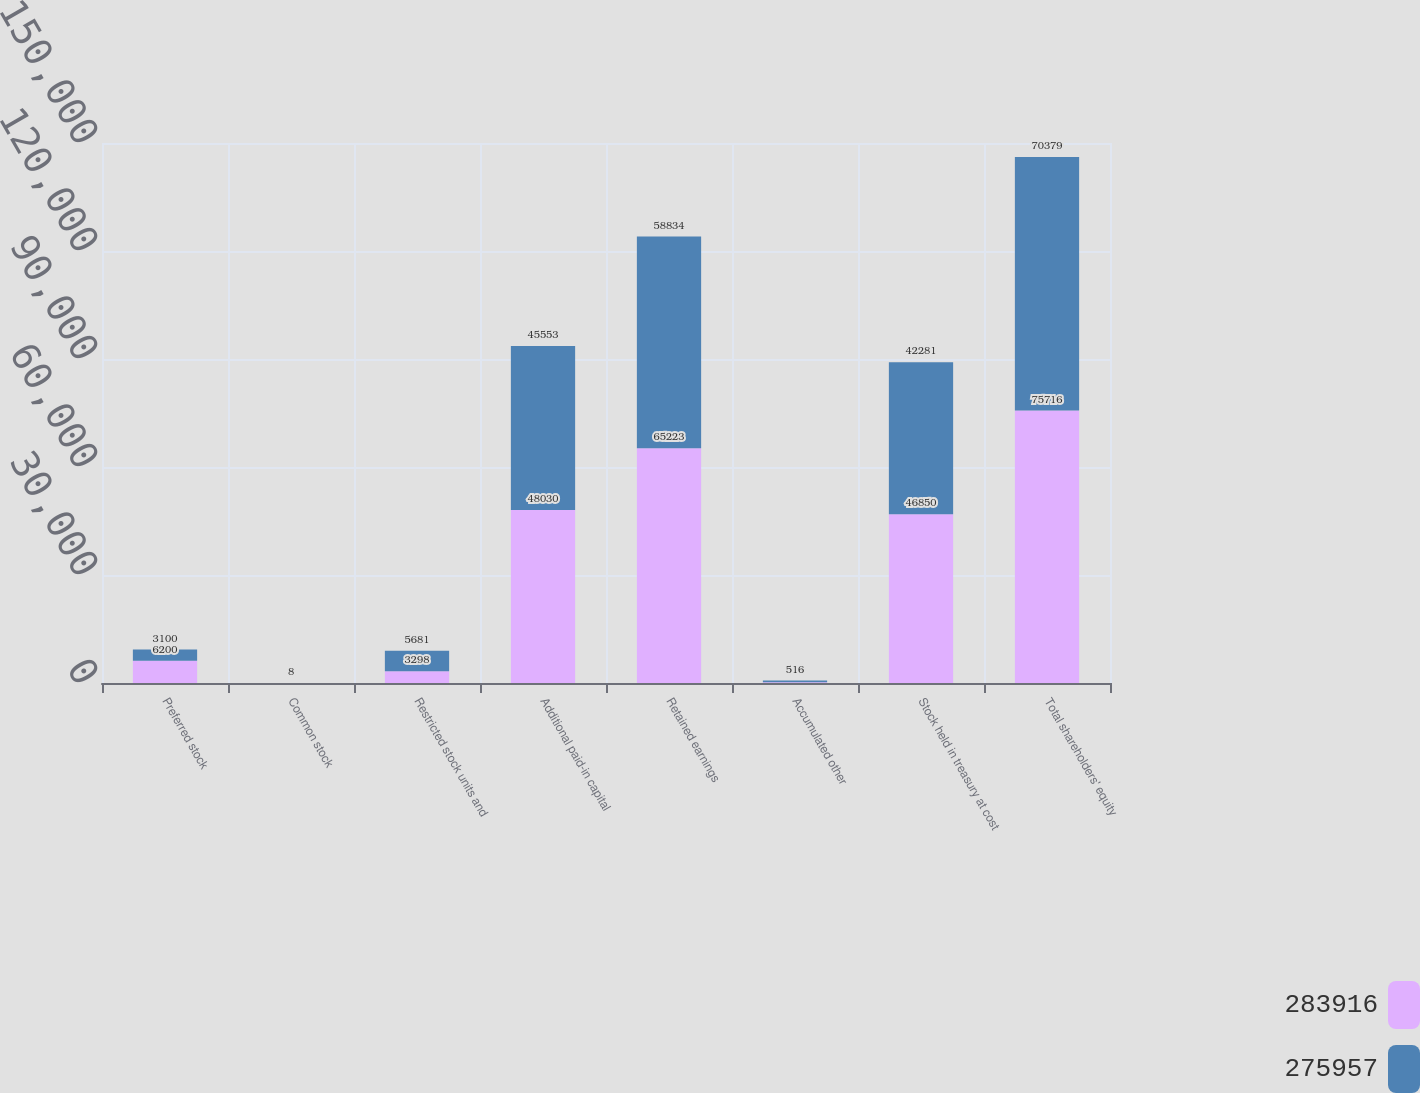<chart> <loc_0><loc_0><loc_500><loc_500><stacked_bar_chart><ecel><fcel>Preferred stock<fcel>Common stock<fcel>Restricted stock units and<fcel>Additional paid-in capital<fcel>Retained earnings<fcel>Accumulated other<fcel>Stock held in treasury at cost<fcel>Total shareholders' equity<nl><fcel>283916<fcel>6200<fcel>8<fcel>3298<fcel>48030<fcel>65223<fcel>193<fcel>46850<fcel>75716<nl><fcel>275957<fcel>3100<fcel>8<fcel>5681<fcel>45553<fcel>58834<fcel>516<fcel>42281<fcel>70379<nl></chart> 